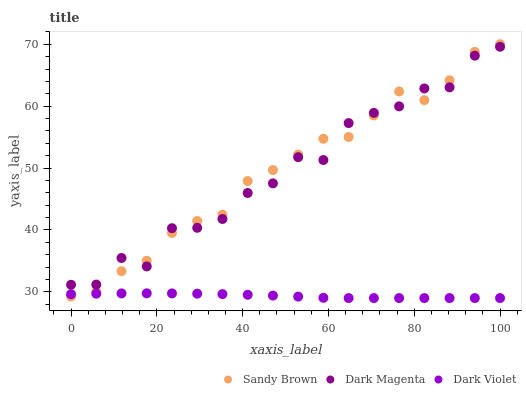Does Dark Violet have the minimum area under the curve?
Answer yes or no. Yes. Does Sandy Brown have the maximum area under the curve?
Answer yes or no. Yes. Does Dark Magenta have the minimum area under the curve?
Answer yes or no. No. Does Dark Magenta have the maximum area under the curve?
Answer yes or no. No. Is Dark Violet the smoothest?
Answer yes or no. Yes. Is Dark Magenta the roughest?
Answer yes or no. Yes. Is Dark Magenta the smoothest?
Answer yes or no. No. Is Dark Violet the roughest?
Answer yes or no. No. Does Dark Violet have the lowest value?
Answer yes or no. Yes. Does Dark Magenta have the lowest value?
Answer yes or no. No. Does Sandy Brown have the highest value?
Answer yes or no. Yes. Does Dark Magenta have the highest value?
Answer yes or no. No. Is Dark Violet less than Dark Magenta?
Answer yes or no. Yes. Is Dark Magenta greater than Dark Violet?
Answer yes or no. Yes. Does Sandy Brown intersect Dark Violet?
Answer yes or no. Yes. Is Sandy Brown less than Dark Violet?
Answer yes or no. No. Is Sandy Brown greater than Dark Violet?
Answer yes or no. No. Does Dark Violet intersect Dark Magenta?
Answer yes or no. No. 